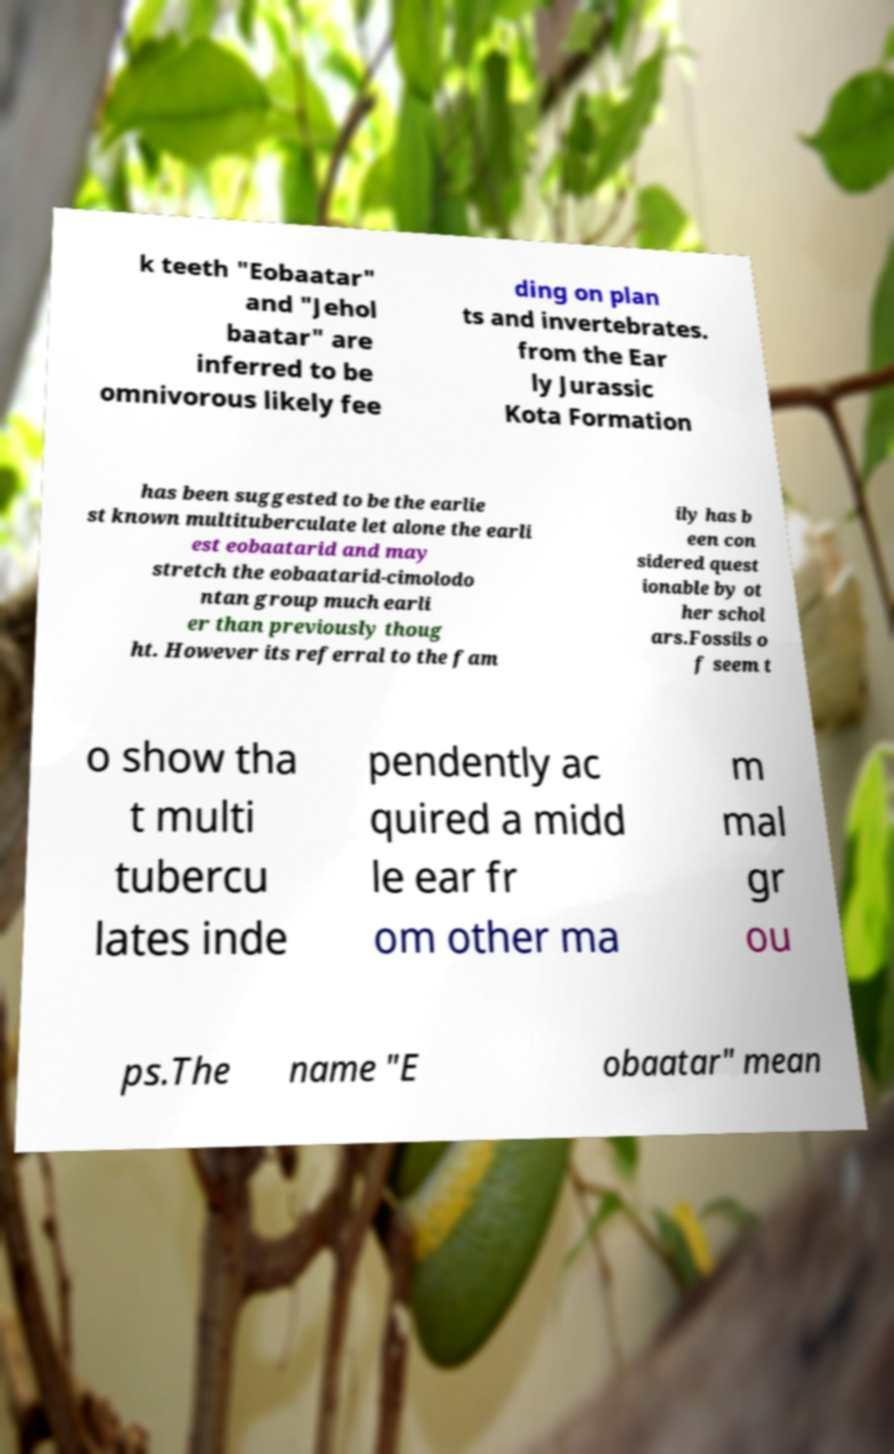Please identify and transcribe the text found in this image. k teeth "Eobaatar" and "Jehol baatar" are inferred to be omnivorous likely fee ding on plan ts and invertebrates. from the Ear ly Jurassic Kota Formation has been suggested to be the earlie st known multituberculate let alone the earli est eobaatarid and may stretch the eobaatarid-cimolodo ntan group much earli er than previously thoug ht. However its referral to the fam ily has b een con sidered quest ionable by ot her schol ars.Fossils o f seem t o show tha t multi tubercu lates inde pendently ac quired a midd le ear fr om other ma m mal gr ou ps.The name "E obaatar" mean 